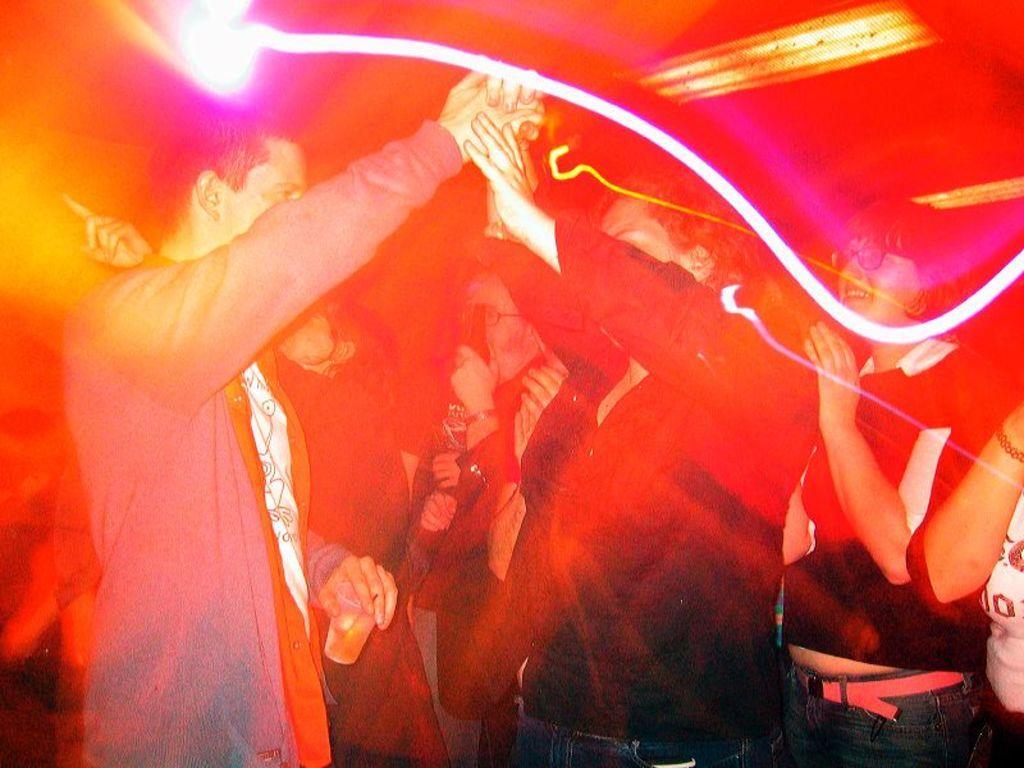Describe this image in one or two sentences. In this picture I can see number of people and I see that the man in front is holding a glass in his hand and I see that this picture is colorful. 